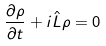Convert formula to latex. <formula><loc_0><loc_0><loc_500><loc_500>\frac { \partial \rho } { \partial t } + i \hat { L } \rho = 0</formula> 